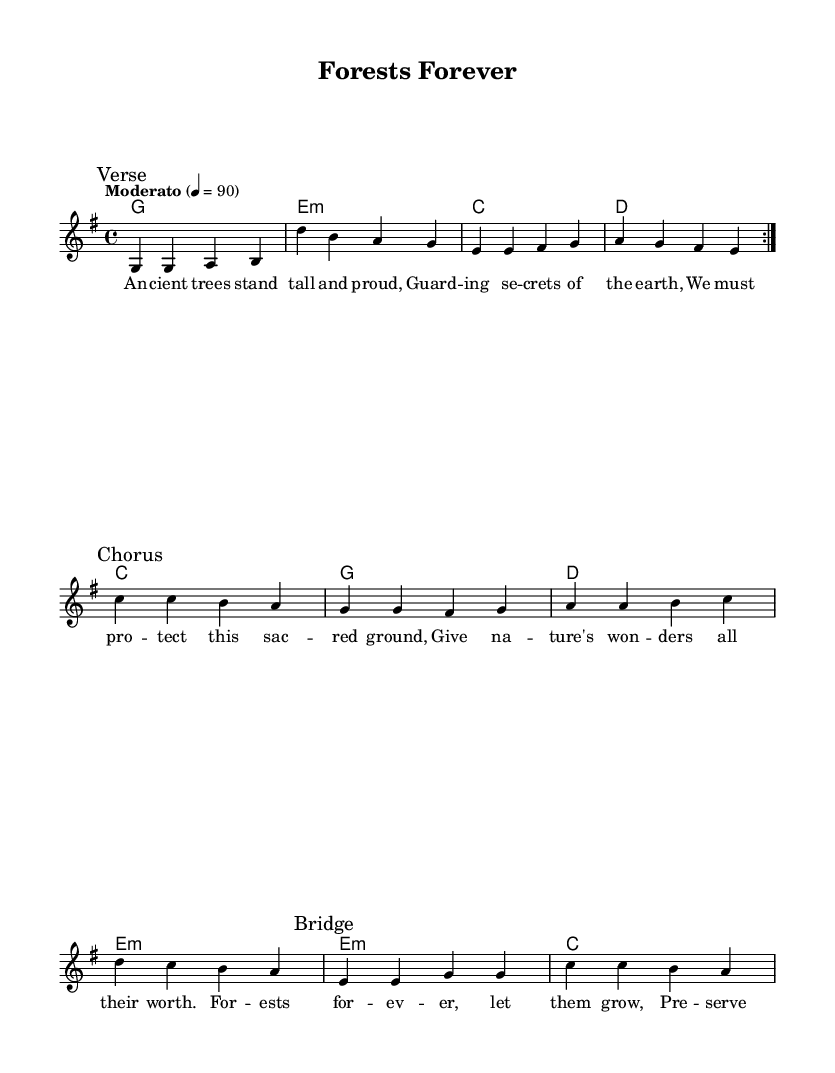What is the key signature of this music? The key signature is indicated at the beginning of the staff and shows one sharp, which corresponds to G major.
Answer: G major What is the time signature of this music? The time signature is displayed at the beginning of the score, showing four beats per measure, which is 4/4.
Answer: 4/4 What is the tempo marking for this piece? The tempo marking "Moderato" appears at the beginning, indicating a moderate speed, along with a specific metronome mark of 90 beats per minute.
Answer: Moderato How many verses are in the music? By analyzing the structure presented in the sheet music, there is one verse section marked, and it repeats, indicating there is one verse overall.
Answer: One What poetic device is used in the lyrics of the chorus? The lyrics of the chorus employ repetition with the phrase "Forests forever" highlighted, emphasizing the main theme of conservation.
Answer: Repetition What environmental message does the bridge convey? The bridge lyrics suggest a nurturing action ("Plant a seed, watch it grow"), indicating a focus on taking care of nature and promoting growth.
Answer: Nurturing 